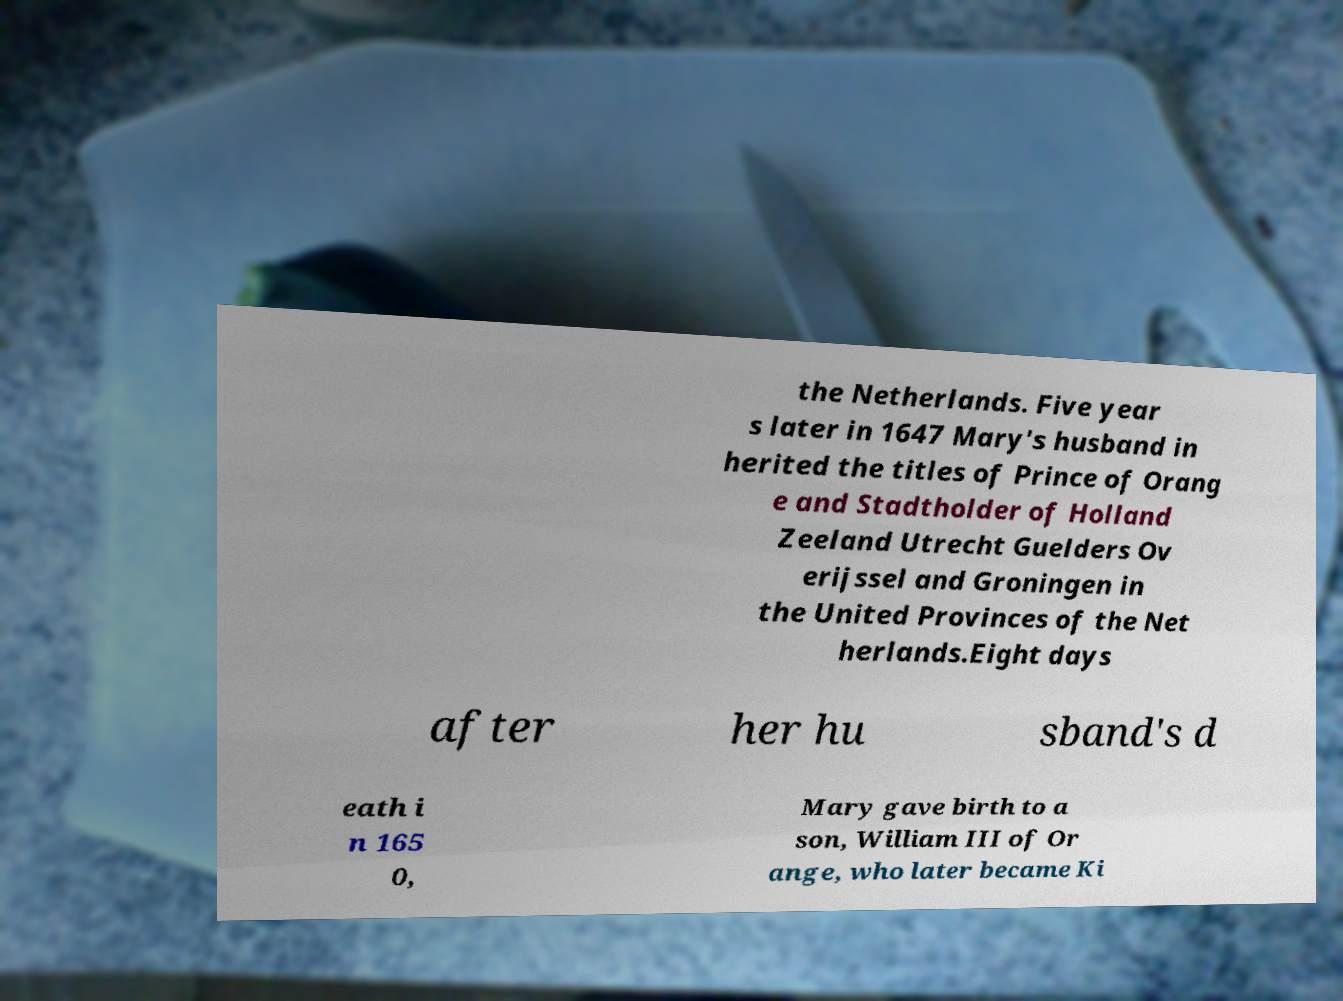I need the written content from this picture converted into text. Can you do that? the Netherlands. Five year s later in 1647 Mary's husband in herited the titles of Prince of Orang e and Stadtholder of Holland Zeeland Utrecht Guelders Ov erijssel and Groningen in the United Provinces of the Net herlands.Eight days after her hu sband's d eath i n 165 0, Mary gave birth to a son, William III of Or ange, who later became Ki 